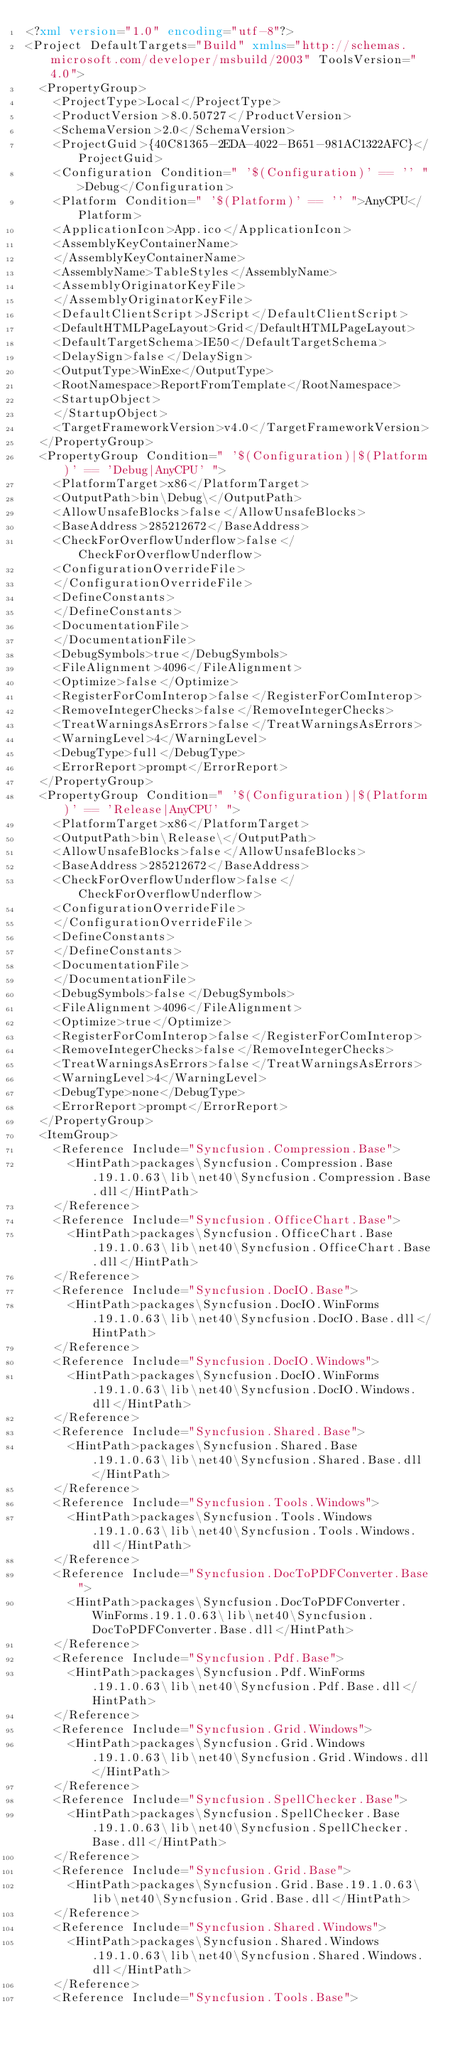<code> <loc_0><loc_0><loc_500><loc_500><_XML_><?xml version="1.0" encoding="utf-8"?>
<Project DefaultTargets="Build" xmlns="http://schemas.microsoft.com/developer/msbuild/2003" ToolsVersion="4.0">
  <PropertyGroup>
    <ProjectType>Local</ProjectType>
    <ProductVersion>8.0.50727</ProductVersion>
    <SchemaVersion>2.0</SchemaVersion>
    <ProjectGuid>{40C81365-2EDA-4022-B651-981AC1322AFC}</ProjectGuid>
    <Configuration Condition=" '$(Configuration)' == '' ">Debug</Configuration>
    <Platform Condition=" '$(Platform)' == '' ">AnyCPU</Platform>
    <ApplicationIcon>App.ico</ApplicationIcon>
    <AssemblyKeyContainerName>
    </AssemblyKeyContainerName>
    <AssemblyName>TableStyles</AssemblyName>
    <AssemblyOriginatorKeyFile>
    </AssemblyOriginatorKeyFile>
    <DefaultClientScript>JScript</DefaultClientScript>
    <DefaultHTMLPageLayout>Grid</DefaultHTMLPageLayout>
    <DefaultTargetSchema>IE50</DefaultTargetSchema>
    <DelaySign>false</DelaySign>
    <OutputType>WinExe</OutputType>
    <RootNamespace>ReportFromTemplate</RootNamespace>
    <StartupObject>
    </StartupObject>
    <TargetFrameworkVersion>v4.0</TargetFrameworkVersion>
  </PropertyGroup>
  <PropertyGroup Condition=" '$(Configuration)|$(Platform)' == 'Debug|AnyCPU' ">
    <PlatformTarget>x86</PlatformTarget>
    <OutputPath>bin\Debug\</OutputPath>
    <AllowUnsafeBlocks>false</AllowUnsafeBlocks>
    <BaseAddress>285212672</BaseAddress>
    <CheckForOverflowUnderflow>false</CheckForOverflowUnderflow>
    <ConfigurationOverrideFile>
    </ConfigurationOverrideFile>
    <DefineConstants>
    </DefineConstants>
    <DocumentationFile>
    </DocumentationFile>
    <DebugSymbols>true</DebugSymbols>
    <FileAlignment>4096</FileAlignment>
    <Optimize>false</Optimize>
    <RegisterForComInterop>false</RegisterForComInterop>
    <RemoveIntegerChecks>false</RemoveIntegerChecks>
    <TreatWarningsAsErrors>false</TreatWarningsAsErrors>
    <WarningLevel>4</WarningLevel>
    <DebugType>full</DebugType>
    <ErrorReport>prompt</ErrorReport>
  </PropertyGroup>
  <PropertyGroup Condition=" '$(Configuration)|$(Platform)' == 'Release|AnyCPU' ">
    <PlatformTarget>x86</PlatformTarget>
    <OutputPath>bin\Release\</OutputPath>
    <AllowUnsafeBlocks>false</AllowUnsafeBlocks>
    <BaseAddress>285212672</BaseAddress>
    <CheckForOverflowUnderflow>false</CheckForOverflowUnderflow>
    <ConfigurationOverrideFile>
    </ConfigurationOverrideFile>
    <DefineConstants>
    </DefineConstants>
    <DocumentationFile>
    </DocumentationFile>
    <DebugSymbols>false</DebugSymbols>
    <FileAlignment>4096</FileAlignment>
    <Optimize>true</Optimize>
    <RegisterForComInterop>false</RegisterForComInterop>
    <RemoveIntegerChecks>false</RemoveIntegerChecks>
    <TreatWarningsAsErrors>false</TreatWarningsAsErrors>
    <WarningLevel>4</WarningLevel>
    <DebugType>none</DebugType>
    <ErrorReport>prompt</ErrorReport>
  </PropertyGroup>
  <ItemGroup>
    <Reference Include="Syncfusion.Compression.Base">
      <HintPath>packages\Syncfusion.Compression.Base.19.1.0.63\lib\net40\Syncfusion.Compression.Base.dll</HintPath>
    </Reference>
    <Reference Include="Syncfusion.OfficeChart.Base">
      <HintPath>packages\Syncfusion.OfficeChart.Base.19.1.0.63\lib\net40\Syncfusion.OfficeChart.Base.dll</HintPath>
    </Reference>
    <Reference Include="Syncfusion.DocIO.Base">
      <HintPath>packages\Syncfusion.DocIO.WinForms.19.1.0.63\lib\net40\Syncfusion.DocIO.Base.dll</HintPath>
    </Reference>
    <Reference Include="Syncfusion.DocIO.Windows">
      <HintPath>packages\Syncfusion.DocIO.WinForms.19.1.0.63\lib\net40\Syncfusion.DocIO.Windows.dll</HintPath>
    </Reference>
    <Reference Include="Syncfusion.Shared.Base">
      <HintPath>packages\Syncfusion.Shared.Base.19.1.0.63\lib\net40\Syncfusion.Shared.Base.dll</HintPath>
    </Reference>
    <Reference Include="Syncfusion.Tools.Windows">
      <HintPath>packages\Syncfusion.Tools.Windows.19.1.0.63\lib\net40\Syncfusion.Tools.Windows.dll</HintPath>
    </Reference>
    <Reference Include="Syncfusion.DocToPDFConverter.Base">
      <HintPath>packages\Syncfusion.DocToPDFConverter.WinForms.19.1.0.63\lib\net40\Syncfusion.DocToPDFConverter.Base.dll</HintPath>
    </Reference>
    <Reference Include="Syncfusion.Pdf.Base">
      <HintPath>packages\Syncfusion.Pdf.WinForms.19.1.0.63\lib\net40\Syncfusion.Pdf.Base.dll</HintPath>
    </Reference>
    <Reference Include="Syncfusion.Grid.Windows">
      <HintPath>packages\Syncfusion.Grid.Windows.19.1.0.63\lib\net40\Syncfusion.Grid.Windows.dll</HintPath>
    </Reference>
    <Reference Include="Syncfusion.SpellChecker.Base">
      <HintPath>packages\Syncfusion.SpellChecker.Base.19.1.0.63\lib\net40\Syncfusion.SpellChecker.Base.dll</HintPath>
    </Reference>
    <Reference Include="Syncfusion.Grid.Base">
      <HintPath>packages\Syncfusion.Grid.Base.19.1.0.63\lib\net40\Syncfusion.Grid.Base.dll</HintPath>
    </Reference>
    <Reference Include="Syncfusion.Shared.Windows">
      <HintPath>packages\Syncfusion.Shared.Windows.19.1.0.63\lib\net40\Syncfusion.Shared.Windows.dll</HintPath>
    </Reference>
    <Reference Include="Syncfusion.Tools.Base"></code> 